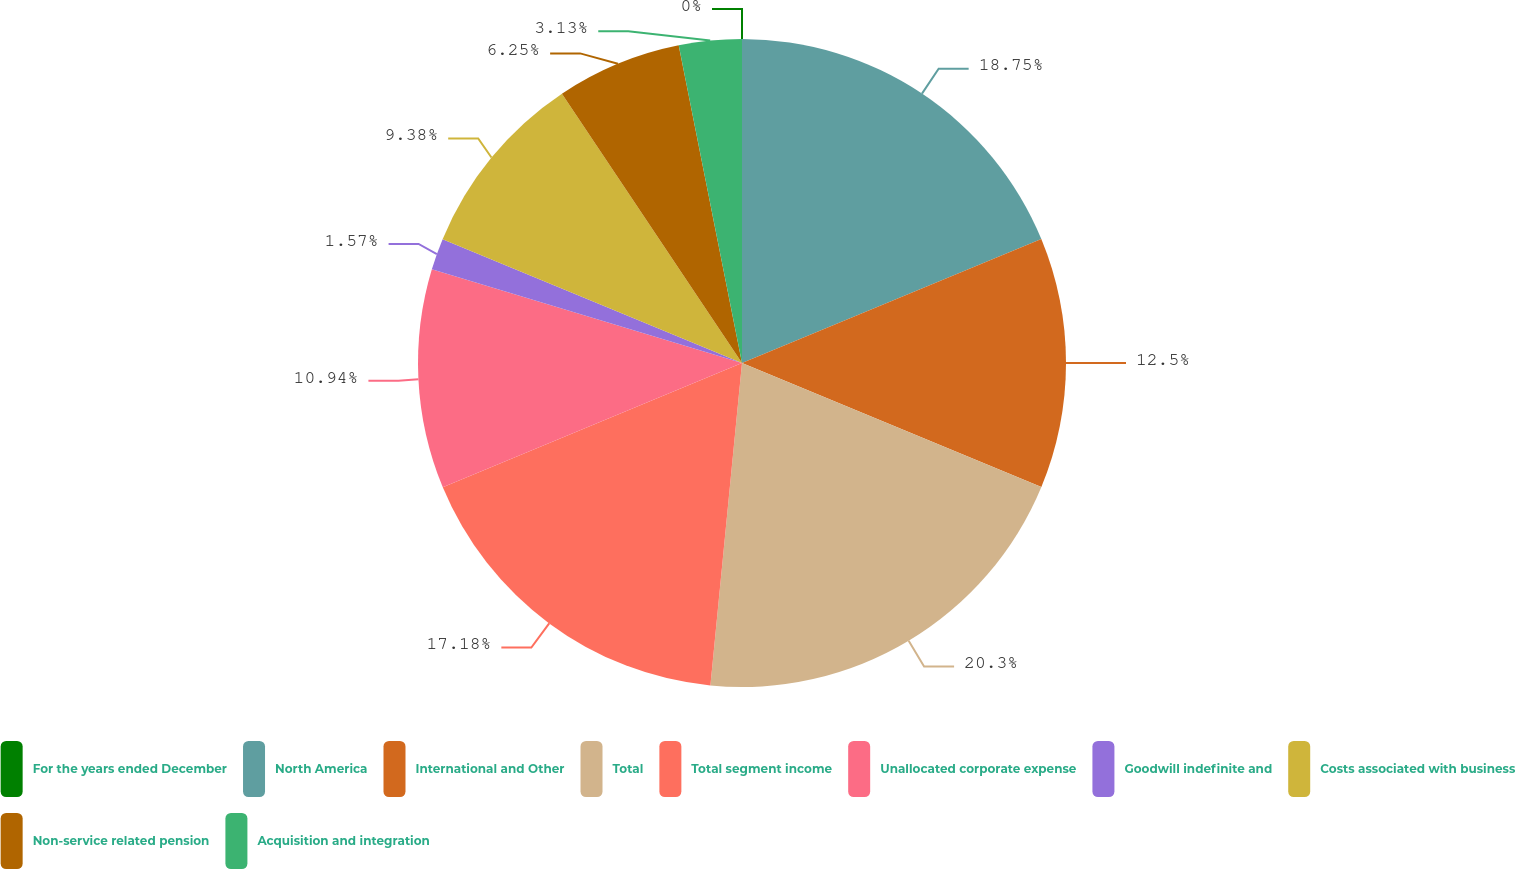<chart> <loc_0><loc_0><loc_500><loc_500><pie_chart><fcel>For the years ended December<fcel>North America<fcel>International and Other<fcel>Total<fcel>Total segment income<fcel>Unallocated corporate expense<fcel>Goodwill indefinite and<fcel>Costs associated with business<fcel>Non-service related pension<fcel>Acquisition and integration<nl><fcel>0.0%<fcel>18.75%<fcel>12.5%<fcel>20.31%<fcel>17.18%<fcel>10.94%<fcel>1.57%<fcel>9.38%<fcel>6.25%<fcel>3.13%<nl></chart> 